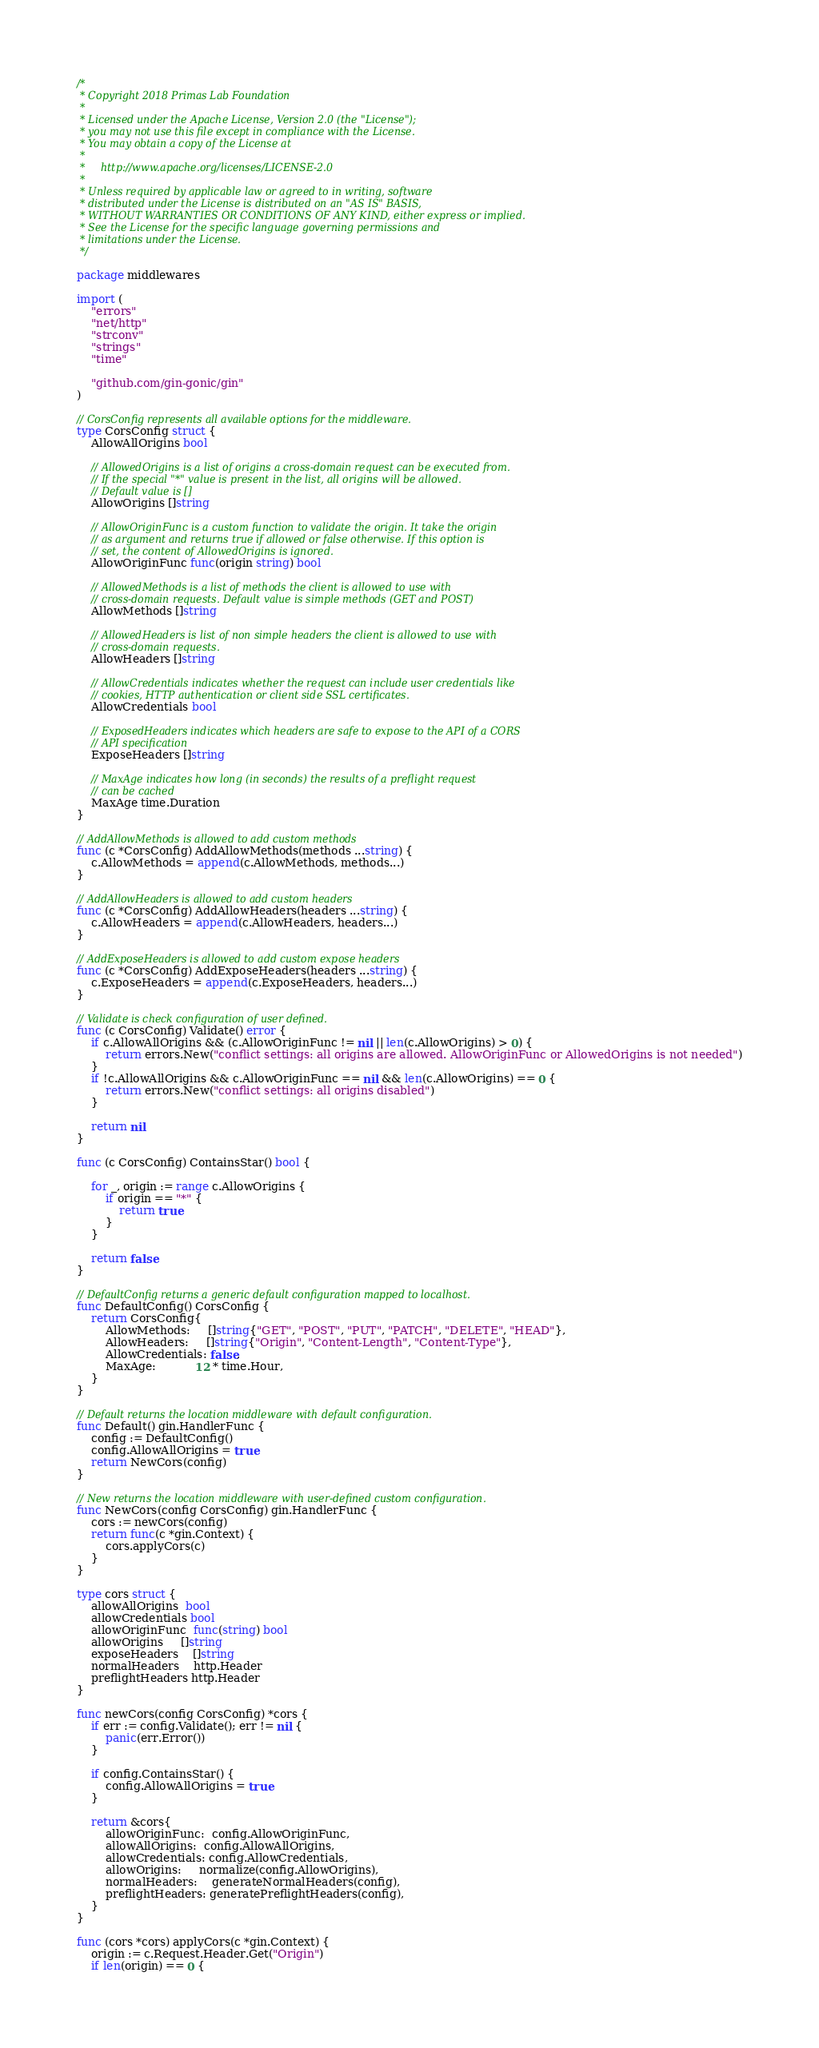Convert code to text. <code><loc_0><loc_0><loc_500><loc_500><_Go_>/*
 * Copyright 2018 Primas Lab Foundation
 *
 * Licensed under the Apache License, Version 2.0 (the "License");
 * you may not use this file except in compliance with the License.
 * You may obtain a copy of the License at
 *
 *     http://www.apache.org/licenses/LICENSE-2.0
 *
 * Unless required by applicable law or agreed to in writing, software
 * distributed under the License is distributed on an "AS IS" BASIS,
 * WITHOUT WARRANTIES OR CONDITIONS OF ANY KIND, either express or implied.
 * See the License for the specific language governing permissions and
 * limitations under the License.
 */

package middlewares

import (
	"errors"
	"net/http"
	"strconv"
	"strings"
	"time"

	"github.com/gin-gonic/gin"
)

// CorsConfig represents all available options for the middleware.
type CorsConfig struct {
	AllowAllOrigins bool

	// AllowedOrigins is a list of origins a cross-domain request can be executed from.
	// If the special "*" value is present in the list, all origins will be allowed.
	// Default value is []
	AllowOrigins []string

	// AllowOriginFunc is a custom function to validate the origin. It take the origin
	// as argument and returns true if allowed or false otherwise. If this option is
	// set, the content of AllowedOrigins is ignored.
	AllowOriginFunc func(origin string) bool

	// AllowedMethods is a list of methods the client is allowed to use with
	// cross-domain requests. Default value is simple methods (GET and POST)
	AllowMethods []string

	// AllowedHeaders is list of non simple headers the client is allowed to use with
	// cross-domain requests.
	AllowHeaders []string

	// AllowCredentials indicates whether the request can include user credentials like
	// cookies, HTTP authentication or client side SSL certificates.
	AllowCredentials bool

	// ExposedHeaders indicates which headers are safe to expose to the API of a CORS
	// API specification
	ExposeHeaders []string

	// MaxAge indicates how long (in seconds) the results of a preflight request
	// can be cached
	MaxAge time.Duration
}

// AddAllowMethods is allowed to add custom methods
func (c *CorsConfig) AddAllowMethods(methods ...string) {
	c.AllowMethods = append(c.AllowMethods, methods...)
}

// AddAllowHeaders is allowed to add custom headers
func (c *CorsConfig) AddAllowHeaders(headers ...string) {
	c.AllowHeaders = append(c.AllowHeaders, headers...)
}

// AddExposeHeaders is allowed to add custom expose headers
func (c *CorsConfig) AddExposeHeaders(headers ...string) {
	c.ExposeHeaders = append(c.ExposeHeaders, headers...)
}

// Validate is check configuration of user defined.
func (c CorsConfig) Validate() error {
	if c.AllowAllOrigins && (c.AllowOriginFunc != nil || len(c.AllowOrigins) > 0) {
		return errors.New("conflict settings: all origins are allowed. AllowOriginFunc or AllowedOrigins is not needed")
	}
	if !c.AllowAllOrigins && c.AllowOriginFunc == nil && len(c.AllowOrigins) == 0 {
		return errors.New("conflict settings: all origins disabled")
	}

	return nil
}

func (c CorsConfig) ContainsStar() bool {

	for _, origin := range c.AllowOrigins {
		if origin == "*" {
			return true
		}
	}

	return false
}

// DefaultConfig returns a generic default configuration mapped to localhost.
func DefaultConfig() CorsConfig {
	return CorsConfig{
		AllowMethods:     []string{"GET", "POST", "PUT", "PATCH", "DELETE", "HEAD"},
		AllowHeaders:     []string{"Origin", "Content-Length", "Content-Type"},
		AllowCredentials: false,
		MaxAge:           12 * time.Hour,
	}
}

// Default returns the location middleware with default configuration.
func Default() gin.HandlerFunc {
	config := DefaultConfig()
	config.AllowAllOrigins = true
	return NewCors(config)
}

// New returns the location middleware with user-defined custom configuration.
func NewCors(config CorsConfig) gin.HandlerFunc {
	cors := newCors(config)
	return func(c *gin.Context) {
		cors.applyCors(c)
	}
}

type cors struct {
	allowAllOrigins  bool
	allowCredentials bool
	allowOriginFunc  func(string) bool
	allowOrigins     []string
	exposeHeaders    []string
	normalHeaders    http.Header
	preflightHeaders http.Header
}

func newCors(config CorsConfig) *cors {
	if err := config.Validate(); err != nil {
		panic(err.Error())
	}

	if config.ContainsStar() {
		config.AllowAllOrigins = true
	}

	return &cors{
		allowOriginFunc:  config.AllowOriginFunc,
		allowAllOrigins:  config.AllowAllOrigins,
		allowCredentials: config.AllowCredentials,
		allowOrigins:     normalize(config.AllowOrigins),
		normalHeaders:    generateNormalHeaders(config),
		preflightHeaders: generatePreflightHeaders(config),
	}
}

func (cors *cors) applyCors(c *gin.Context) {
	origin := c.Request.Header.Get("Origin")
	if len(origin) == 0 {</code> 